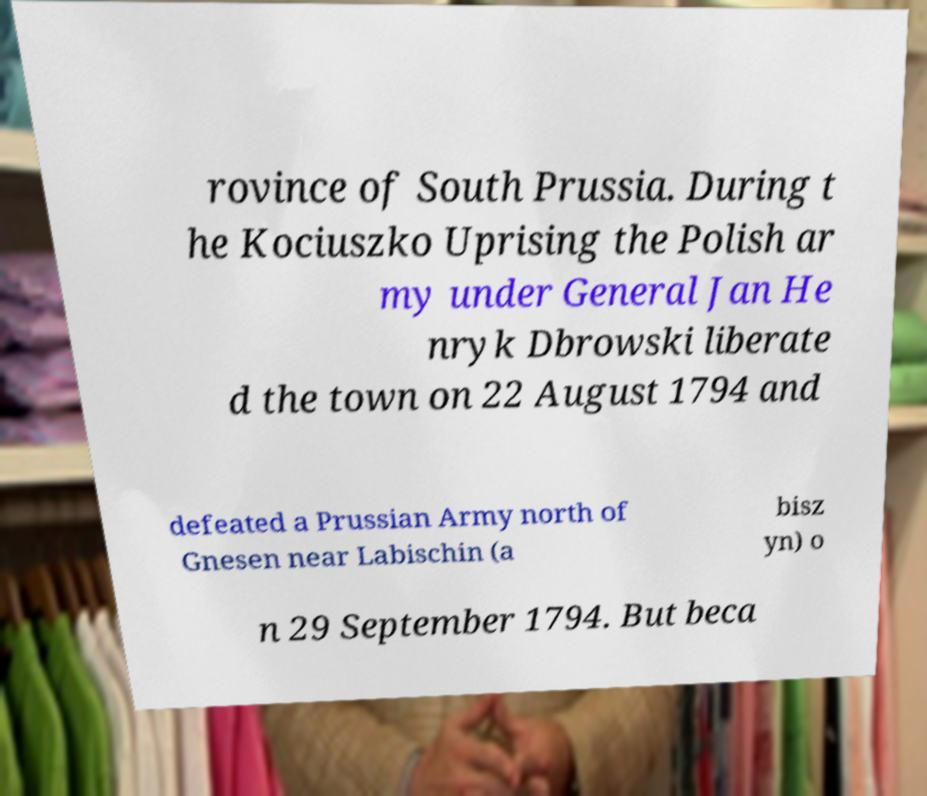For documentation purposes, I need the text within this image transcribed. Could you provide that? rovince of South Prussia. During t he Kociuszko Uprising the Polish ar my under General Jan He nryk Dbrowski liberate d the town on 22 August 1794 and defeated a Prussian Army north of Gnesen near Labischin (a bisz yn) o n 29 September 1794. But beca 